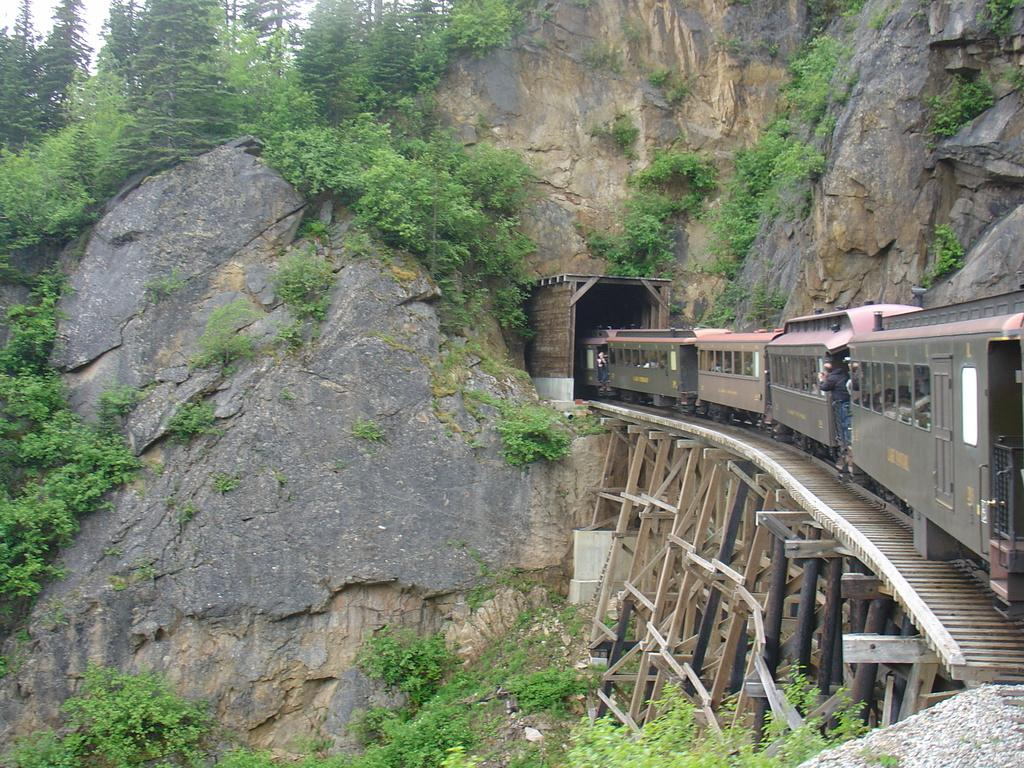What is the main subject of the image? There is a train on a track in the image. What type of natural elements can be seen in the image? Plants and trees are visible in the image. What geographical feature can be seen in the image? There is a hill visible in the image. How many potatoes are present in the image? There are no potatoes present in the image. 